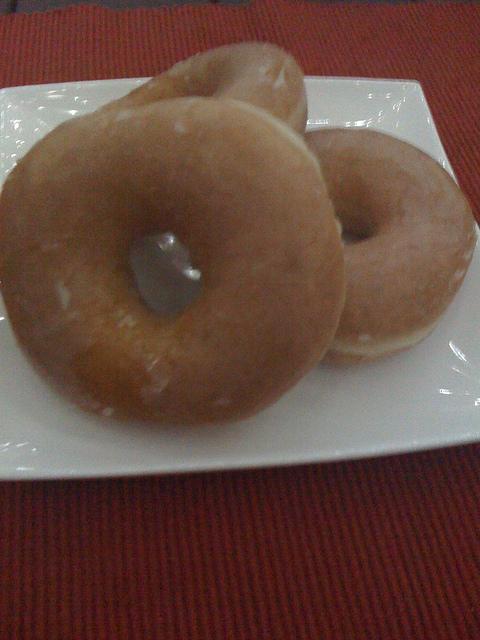Is this a glazed donut?
Quick response, please. Yes. How many donuts are on the plate?
Quick response, please. 3. Is there almonds on the doughnut?
Be succinct. No. What shape is the plate?
Keep it brief. Square. 